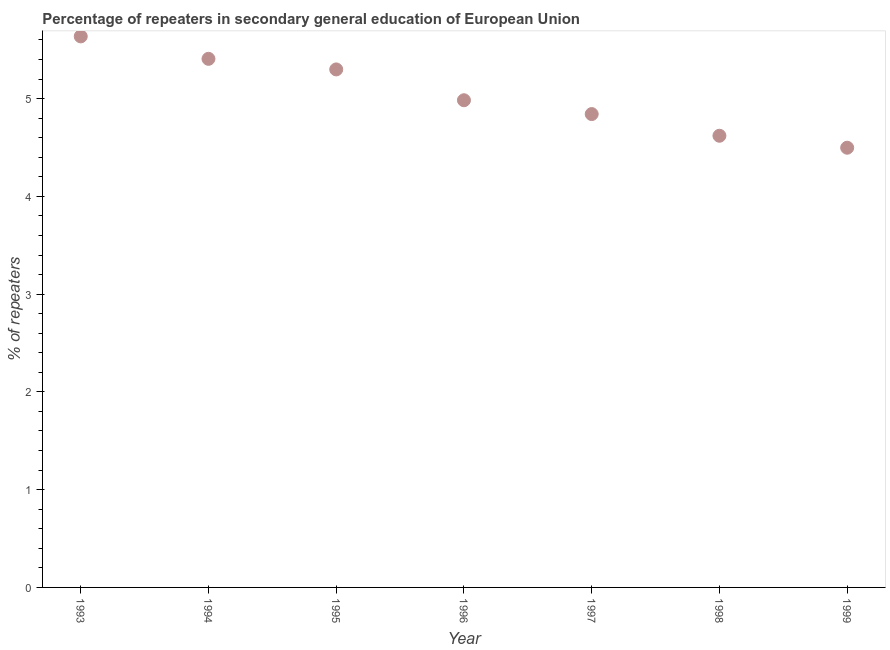What is the percentage of repeaters in 1998?
Offer a terse response. 4.62. Across all years, what is the maximum percentage of repeaters?
Your answer should be very brief. 5.64. Across all years, what is the minimum percentage of repeaters?
Offer a terse response. 4.5. What is the sum of the percentage of repeaters?
Ensure brevity in your answer.  35.28. What is the difference between the percentage of repeaters in 1993 and 1996?
Offer a very short reply. 0.65. What is the average percentage of repeaters per year?
Provide a succinct answer. 5.04. What is the median percentage of repeaters?
Make the answer very short. 4.98. Do a majority of the years between 1993 and 1996 (inclusive) have percentage of repeaters greater than 4.2 %?
Provide a succinct answer. Yes. What is the ratio of the percentage of repeaters in 1994 to that in 1999?
Your answer should be compact. 1.2. Is the percentage of repeaters in 1993 less than that in 1998?
Ensure brevity in your answer.  No. Is the difference between the percentage of repeaters in 1994 and 1999 greater than the difference between any two years?
Make the answer very short. No. What is the difference between the highest and the second highest percentage of repeaters?
Provide a short and direct response. 0.23. Is the sum of the percentage of repeaters in 1993 and 1999 greater than the maximum percentage of repeaters across all years?
Provide a succinct answer. Yes. What is the difference between the highest and the lowest percentage of repeaters?
Offer a terse response. 1.14. Does the percentage of repeaters monotonically increase over the years?
Offer a terse response. No. How many years are there in the graph?
Provide a short and direct response. 7. Are the values on the major ticks of Y-axis written in scientific E-notation?
Offer a very short reply. No. Does the graph contain any zero values?
Your response must be concise. No. What is the title of the graph?
Provide a short and direct response. Percentage of repeaters in secondary general education of European Union. What is the label or title of the X-axis?
Provide a succinct answer. Year. What is the label or title of the Y-axis?
Offer a very short reply. % of repeaters. What is the % of repeaters in 1993?
Offer a very short reply. 5.64. What is the % of repeaters in 1994?
Your answer should be very brief. 5.41. What is the % of repeaters in 1995?
Make the answer very short. 5.3. What is the % of repeaters in 1996?
Offer a terse response. 4.98. What is the % of repeaters in 1997?
Your answer should be very brief. 4.84. What is the % of repeaters in 1998?
Your answer should be compact. 4.62. What is the % of repeaters in 1999?
Give a very brief answer. 4.5. What is the difference between the % of repeaters in 1993 and 1994?
Ensure brevity in your answer.  0.23. What is the difference between the % of repeaters in 1993 and 1995?
Keep it short and to the point. 0.34. What is the difference between the % of repeaters in 1993 and 1996?
Your response must be concise. 0.65. What is the difference between the % of repeaters in 1993 and 1997?
Offer a terse response. 0.79. What is the difference between the % of repeaters in 1993 and 1998?
Your answer should be compact. 1.02. What is the difference between the % of repeaters in 1993 and 1999?
Make the answer very short. 1.14. What is the difference between the % of repeaters in 1994 and 1995?
Give a very brief answer. 0.11. What is the difference between the % of repeaters in 1994 and 1996?
Your answer should be very brief. 0.42. What is the difference between the % of repeaters in 1994 and 1997?
Offer a very short reply. 0.56. What is the difference between the % of repeaters in 1994 and 1998?
Offer a terse response. 0.79. What is the difference between the % of repeaters in 1994 and 1999?
Offer a very short reply. 0.91. What is the difference between the % of repeaters in 1995 and 1996?
Your answer should be compact. 0.32. What is the difference between the % of repeaters in 1995 and 1997?
Offer a very short reply. 0.46. What is the difference between the % of repeaters in 1995 and 1998?
Your response must be concise. 0.68. What is the difference between the % of repeaters in 1995 and 1999?
Give a very brief answer. 0.8. What is the difference between the % of repeaters in 1996 and 1997?
Provide a succinct answer. 0.14. What is the difference between the % of repeaters in 1996 and 1998?
Ensure brevity in your answer.  0.36. What is the difference between the % of repeaters in 1996 and 1999?
Your answer should be compact. 0.49. What is the difference between the % of repeaters in 1997 and 1998?
Your response must be concise. 0.22. What is the difference between the % of repeaters in 1997 and 1999?
Provide a succinct answer. 0.34. What is the difference between the % of repeaters in 1998 and 1999?
Give a very brief answer. 0.12. What is the ratio of the % of repeaters in 1993 to that in 1994?
Provide a succinct answer. 1.04. What is the ratio of the % of repeaters in 1993 to that in 1995?
Your answer should be compact. 1.06. What is the ratio of the % of repeaters in 1993 to that in 1996?
Keep it short and to the point. 1.13. What is the ratio of the % of repeaters in 1993 to that in 1997?
Keep it short and to the point. 1.16. What is the ratio of the % of repeaters in 1993 to that in 1998?
Provide a short and direct response. 1.22. What is the ratio of the % of repeaters in 1993 to that in 1999?
Offer a very short reply. 1.25. What is the ratio of the % of repeaters in 1994 to that in 1995?
Provide a short and direct response. 1.02. What is the ratio of the % of repeaters in 1994 to that in 1996?
Offer a very short reply. 1.08. What is the ratio of the % of repeaters in 1994 to that in 1997?
Your answer should be compact. 1.12. What is the ratio of the % of repeaters in 1994 to that in 1998?
Offer a very short reply. 1.17. What is the ratio of the % of repeaters in 1994 to that in 1999?
Make the answer very short. 1.2. What is the ratio of the % of repeaters in 1995 to that in 1996?
Give a very brief answer. 1.06. What is the ratio of the % of repeaters in 1995 to that in 1997?
Provide a succinct answer. 1.09. What is the ratio of the % of repeaters in 1995 to that in 1998?
Offer a very short reply. 1.15. What is the ratio of the % of repeaters in 1995 to that in 1999?
Keep it short and to the point. 1.18. What is the ratio of the % of repeaters in 1996 to that in 1998?
Offer a terse response. 1.08. What is the ratio of the % of repeaters in 1996 to that in 1999?
Your answer should be very brief. 1.11. What is the ratio of the % of repeaters in 1997 to that in 1998?
Provide a short and direct response. 1.05. What is the ratio of the % of repeaters in 1997 to that in 1999?
Make the answer very short. 1.08. 